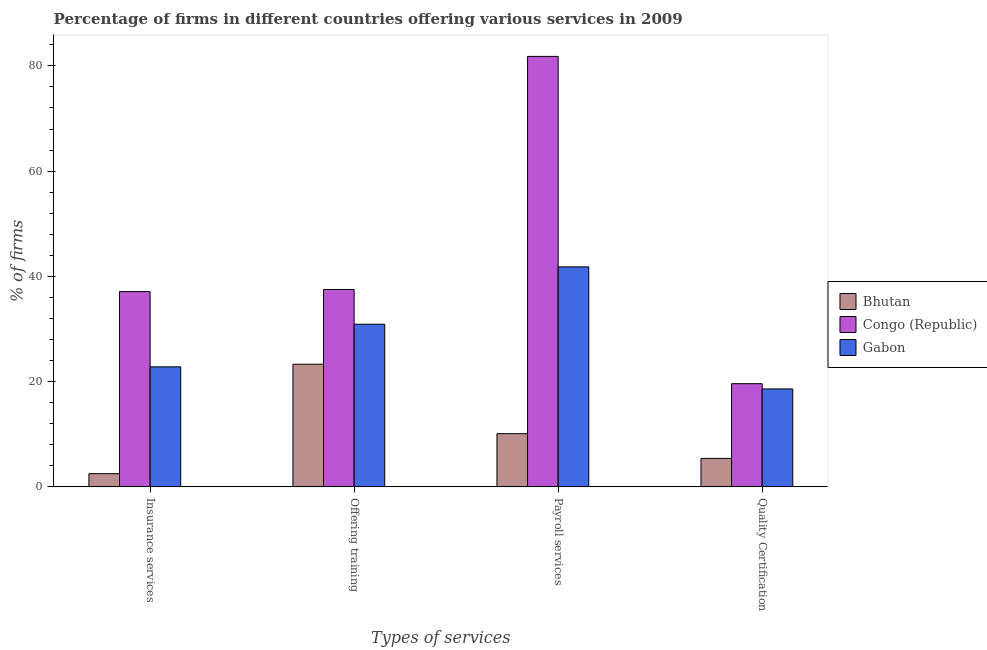How many different coloured bars are there?
Your response must be concise. 3. How many groups of bars are there?
Give a very brief answer. 4. Are the number of bars per tick equal to the number of legend labels?
Keep it short and to the point. Yes. What is the label of the 1st group of bars from the left?
Make the answer very short. Insurance services. Across all countries, what is the maximum percentage of firms offering training?
Ensure brevity in your answer.  37.5. Across all countries, what is the minimum percentage of firms offering training?
Offer a very short reply. 23.3. In which country was the percentage of firms offering quality certification maximum?
Make the answer very short. Congo (Republic). In which country was the percentage of firms offering payroll services minimum?
Provide a succinct answer. Bhutan. What is the total percentage of firms offering training in the graph?
Make the answer very short. 91.7. What is the difference between the percentage of firms offering training in Bhutan and the percentage of firms offering insurance services in Congo (Republic)?
Offer a terse response. -13.8. What is the average percentage of firms offering quality certification per country?
Give a very brief answer. 14.53. What is the difference between the percentage of firms offering training and percentage of firms offering payroll services in Bhutan?
Make the answer very short. 13.2. In how many countries, is the percentage of firms offering quality certification greater than 44 %?
Keep it short and to the point. 0. What is the ratio of the percentage of firms offering training in Gabon to that in Congo (Republic)?
Your answer should be compact. 0.82. What is the difference between the highest and the lowest percentage of firms offering quality certification?
Offer a terse response. 14.2. Is the sum of the percentage of firms offering insurance services in Gabon and Bhutan greater than the maximum percentage of firms offering quality certification across all countries?
Offer a terse response. Yes. Is it the case that in every country, the sum of the percentage of firms offering payroll services and percentage of firms offering quality certification is greater than the sum of percentage of firms offering training and percentage of firms offering insurance services?
Keep it short and to the point. No. What does the 1st bar from the left in Insurance services represents?
Your answer should be very brief. Bhutan. What does the 1st bar from the right in Offering training represents?
Offer a very short reply. Gabon. Is it the case that in every country, the sum of the percentage of firms offering insurance services and percentage of firms offering training is greater than the percentage of firms offering payroll services?
Offer a very short reply. No. How many bars are there?
Give a very brief answer. 12. Are all the bars in the graph horizontal?
Your response must be concise. No. How many countries are there in the graph?
Your answer should be very brief. 3. What is the difference between two consecutive major ticks on the Y-axis?
Your response must be concise. 20. Does the graph contain any zero values?
Give a very brief answer. No. Does the graph contain grids?
Provide a succinct answer. No. Where does the legend appear in the graph?
Your answer should be compact. Center right. What is the title of the graph?
Your answer should be very brief. Percentage of firms in different countries offering various services in 2009. Does "Euro area" appear as one of the legend labels in the graph?
Keep it short and to the point. No. What is the label or title of the X-axis?
Your answer should be very brief. Types of services. What is the label or title of the Y-axis?
Your response must be concise. % of firms. What is the % of firms in Bhutan in Insurance services?
Ensure brevity in your answer.  2.5. What is the % of firms of Congo (Republic) in Insurance services?
Your answer should be compact. 37.1. What is the % of firms in Gabon in Insurance services?
Provide a succinct answer. 22.8. What is the % of firms in Bhutan in Offering training?
Provide a succinct answer. 23.3. What is the % of firms in Congo (Republic) in Offering training?
Your response must be concise. 37.5. What is the % of firms of Gabon in Offering training?
Ensure brevity in your answer.  30.9. What is the % of firms in Bhutan in Payroll services?
Give a very brief answer. 10.1. What is the % of firms in Congo (Republic) in Payroll services?
Your answer should be compact. 81.8. What is the % of firms of Gabon in Payroll services?
Ensure brevity in your answer.  41.8. What is the % of firms of Congo (Republic) in Quality Certification?
Offer a very short reply. 19.6. What is the % of firms of Gabon in Quality Certification?
Your response must be concise. 18.6. Across all Types of services, what is the maximum % of firms in Bhutan?
Your answer should be compact. 23.3. Across all Types of services, what is the maximum % of firms in Congo (Republic)?
Your answer should be compact. 81.8. Across all Types of services, what is the maximum % of firms in Gabon?
Provide a succinct answer. 41.8. Across all Types of services, what is the minimum % of firms of Congo (Republic)?
Ensure brevity in your answer.  19.6. Across all Types of services, what is the minimum % of firms of Gabon?
Provide a succinct answer. 18.6. What is the total % of firms of Bhutan in the graph?
Keep it short and to the point. 41.3. What is the total % of firms in Congo (Republic) in the graph?
Your answer should be very brief. 176. What is the total % of firms of Gabon in the graph?
Offer a terse response. 114.1. What is the difference between the % of firms of Bhutan in Insurance services and that in Offering training?
Offer a very short reply. -20.8. What is the difference between the % of firms in Congo (Republic) in Insurance services and that in Offering training?
Make the answer very short. -0.4. What is the difference between the % of firms in Congo (Republic) in Insurance services and that in Payroll services?
Provide a short and direct response. -44.7. What is the difference between the % of firms of Gabon in Insurance services and that in Payroll services?
Your answer should be compact. -19. What is the difference between the % of firms of Bhutan in Insurance services and that in Quality Certification?
Your answer should be compact. -2.9. What is the difference between the % of firms in Bhutan in Offering training and that in Payroll services?
Ensure brevity in your answer.  13.2. What is the difference between the % of firms of Congo (Republic) in Offering training and that in Payroll services?
Keep it short and to the point. -44.3. What is the difference between the % of firms in Gabon in Offering training and that in Payroll services?
Keep it short and to the point. -10.9. What is the difference between the % of firms in Gabon in Offering training and that in Quality Certification?
Offer a terse response. 12.3. What is the difference between the % of firms in Congo (Republic) in Payroll services and that in Quality Certification?
Your response must be concise. 62.2. What is the difference between the % of firms in Gabon in Payroll services and that in Quality Certification?
Your response must be concise. 23.2. What is the difference between the % of firms in Bhutan in Insurance services and the % of firms in Congo (Republic) in Offering training?
Your answer should be compact. -35. What is the difference between the % of firms of Bhutan in Insurance services and the % of firms of Gabon in Offering training?
Make the answer very short. -28.4. What is the difference between the % of firms of Congo (Republic) in Insurance services and the % of firms of Gabon in Offering training?
Offer a very short reply. 6.2. What is the difference between the % of firms of Bhutan in Insurance services and the % of firms of Congo (Republic) in Payroll services?
Offer a terse response. -79.3. What is the difference between the % of firms in Bhutan in Insurance services and the % of firms in Gabon in Payroll services?
Ensure brevity in your answer.  -39.3. What is the difference between the % of firms of Congo (Republic) in Insurance services and the % of firms of Gabon in Payroll services?
Provide a succinct answer. -4.7. What is the difference between the % of firms of Bhutan in Insurance services and the % of firms of Congo (Republic) in Quality Certification?
Keep it short and to the point. -17.1. What is the difference between the % of firms in Bhutan in Insurance services and the % of firms in Gabon in Quality Certification?
Your answer should be compact. -16.1. What is the difference between the % of firms in Bhutan in Offering training and the % of firms in Congo (Republic) in Payroll services?
Offer a very short reply. -58.5. What is the difference between the % of firms of Bhutan in Offering training and the % of firms of Gabon in Payroll services?
Offer a very short reply. -18.5. What is the difference between the % of firms of Bhutan in Offering training and the % of firms of Congo (Republic) in Quality Certification?
Your answer should be compact. 3.7. What is the difference between the % of firms of Bhutan in Payroll services and the % of firms of Congo (Republic) in Quality Certification?
Offer a very short reply. -9.5. What is the difference between the % of firms of Congo (Republic) in Payroll services and the % of firms of Gabon in Quality Certification?
Your answer should be very brief. 63.2. What is the average % of firms of Bhutan per Types of services?
Offer a terse response. 10.32. What is the average % of firms of Gabon per Types of services?
Give a very brief answer. 28.52. What is the difference between the % of firms of Bhutan and % of firms of Congo (Republic) in Insurance services?
Your answer should be very brief. -34.6. What is the difference between the % of firms in Bhutan and % of firms in Gabon in Insurance services?
Ensure brevity in your answer.  -20.3. What is the difference between the % of firms of Bhutan and % of firms of Congo (Republic) in Offering training?
Offer a terse response. -14.2. What is the difference between the % of firms of Bhutan and % of firms of Congo (Republic) in Payroll services?
Make the answer very short. -71.7. What is the difference between the % of firms of Bhutan and % of firms of Gabon in Payroll services?
Make the answer very short. -31.7. What is the difference between the % of firms of Bhutan and % of firms of Gabon in Quality Certification?
Your answer should be compact. -13.2. What is the difference between the % of firms of Congo (Republic) and % of firms of Gabon in Quality Certification?
Your response must be concise. 1. What is the ratio of the % of firms of Bhutan in Insurance services to that in Offering training?
Provide a short and direct response. 0.11. What is the ratio of the % of firms of Congo (Republic) in Insurance services to that in Offering training?
Give a very brief answer. 0.99. What is the ratio of the % of firms in Gabon in Insurance services to that in Offering training?
Your answer should be compact. 0.74. What is the ratio of the % of firms of Bhutan in Insurance services to that in Payroll services?
Ensure brevity in your answer.  0.25. What is the ratio of the % of firms in Congo (Republic) in Insurance services to that in Payroll services?
Provide a succinct answer. 0.45. What is the ratio of the % of firms in Gabon in Insurance services to that in Payroll services?
Give a very brief answer. 0.55. What is the ratio of the % of firms in Bhutan in Insurance services to that in Quality Certification?
Give a very brief answer. 0.46. What is the ratio of the % of firms in Congo (Republic) in Insurance services to that in Quality Certification?
Your answer should be compact. 1.89. What is the ratio of the % of firms of Gabon in Insurance services to that in Quality Certification?
Provide a short and direct response. 1.23. What is the ratio of the % of firms in Bhutan in Offering training to that in Payroll services?
Keep it short and to the point. 2.31. What is the ratio of the % of firms in Congo (Republic) in Offering training to that in Payroll services?
Offer a very short reply. 0.46. What is the ratio of the % of firms in Gabon in Offering training to that in Payroll services?
Offer a very short reply. 0.74. What is the ratio of the % of firms of Bhutan in Offering training to that in Quality Certification?
Your response must be concise. 4.31. What is the ratio of the % of firms in Congo (Republic) in Offering training to that in Quality Certification?
Offer a very short reply. 1.91. What is the ratio of the % of firms in Gabon in Offering training to that in Quality Certification?
Offer a very short reply. 1.66. What is the ratio of the % of firms of Bhutan in Payroll services to that in Quality Certification?
Your answer should be very brief. 1.87. What is the ratio of the % of firms in Congo (Republic) in Payroll services to that in Quality Certification?
Keep it short and to the point. 4.17. What is the ratio of the % of firms in Gabon in Payroll services to that in Quality Certification?
Give a very brief answer. 2.25. What is the difference between the highest and the second highest % of firms of Bhutan?
Ensure brevity in your answer.  13.2. What is the difference between the highest and the second highest % of firms in Congo (Republic)?
Give a very brief answer. 44.3. What is the difference between the highest and the second highest % of firms of Gabon?
Your answer should be very brief. 10.9. What is the difference between the highest and the lowest % of firms in Bhutan?
Keep it short and to the point. 20.8. What is the difference between the highest and the lowest % of firms in Congo (Republic)?
Give a very brief answer. 62.2. What is the difference between the highest and the lowest % of firms in Gabon?
Your answer should be very brief. 23.2. 